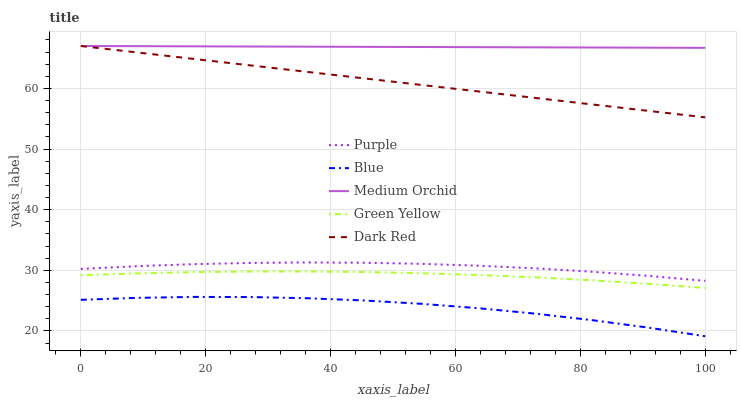Does Blue have the minimum area under the curve?
Answer yes or no. Yes. Does Medium Orchid have the maximum area under the curve?
Answer yes or no. Yes. Does Green Yellow have the minimum area under the curve?
Answer yes or no. No. Does Green Yellow have the maximum area under the curve?
Answer yes or no. No. Is Medium Orchid the smoothest?
Answer yes or no. Yes. Is Blue the roughest?
Answer yes or no. Yes. Is Green Yellow the smoothest?
Answer yes or no. No. Is Green Yellow the roughest?
Answer yes or no. No. Does Blue have the lowest value?
Answer yes or no. Yes. Does Green Yellow have the lowest value?
Answer yes or no. No. Does Dark Red have the highest value?
Answer yes or no. Yes. Does Green Yellow have the highest value?
Answer yes or no. No. Is Blue less than Dark Red?
Answer yes or no. Yes. Is Purple greater than Blue?
Answer yes or no. Yes. Does Dark Red intersect Medium Orchid?
Answer yes or no. Yes. Is Dark Red less than Medium Orchid?
Answer yes or no. No. Is Dark Red greater than Medium Orchid?
Answer yes or no. No. Does Blue intersect Dark Red?
Answer yes or no. No. 